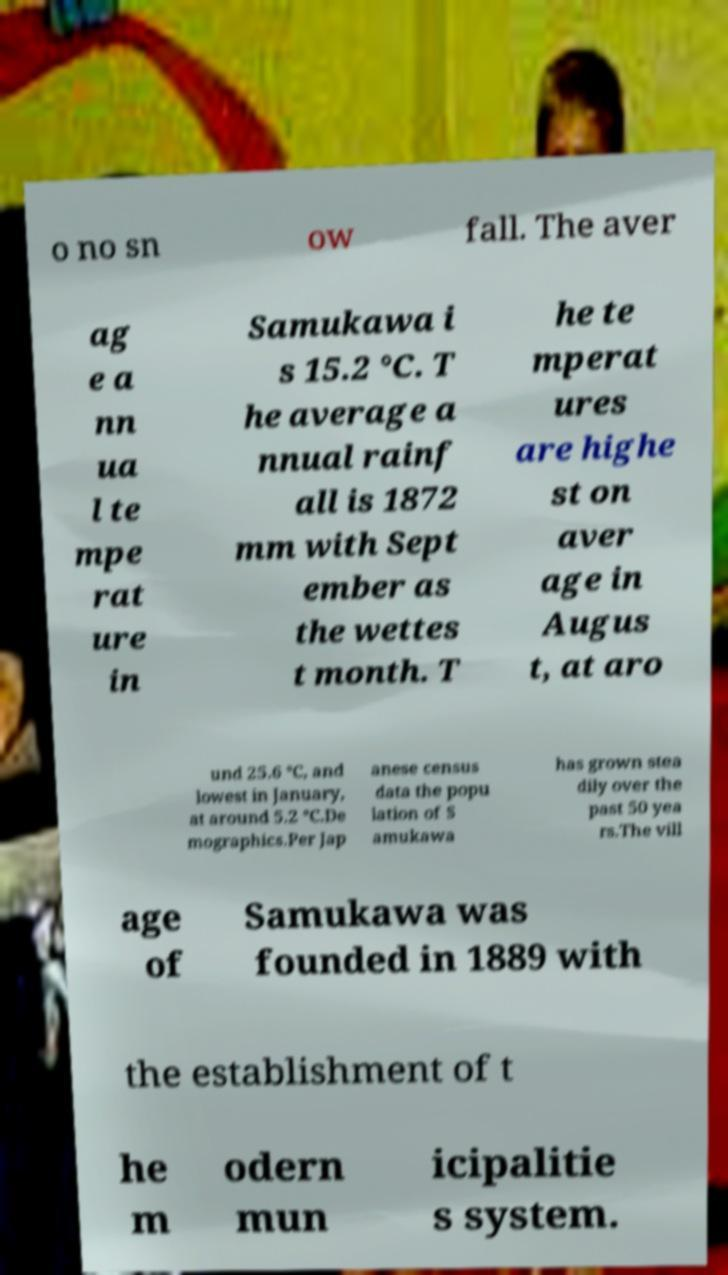Could you assist in decoding the text presented in this image and type it out clearly? o no sn ow fall. The aver ag e a nn ua l te mpe rat ure in Samukawa i s 15.2 °C. T he average a nnual rainf all is 1872 mm with Sept ember as the wettes t month. T he te mperat ures are highe st on aver age in Augus t, at aro und 25.6 °C, and lowest in January, at around 5.2 °C.De mographics.Per Jap anese census data the popu lation of S amukawa has grown stea dily over the past 50 yea rs.The vill age of Samukawa was founded in 1889 with the establishment of t he m odern mun icipalitie s system. 